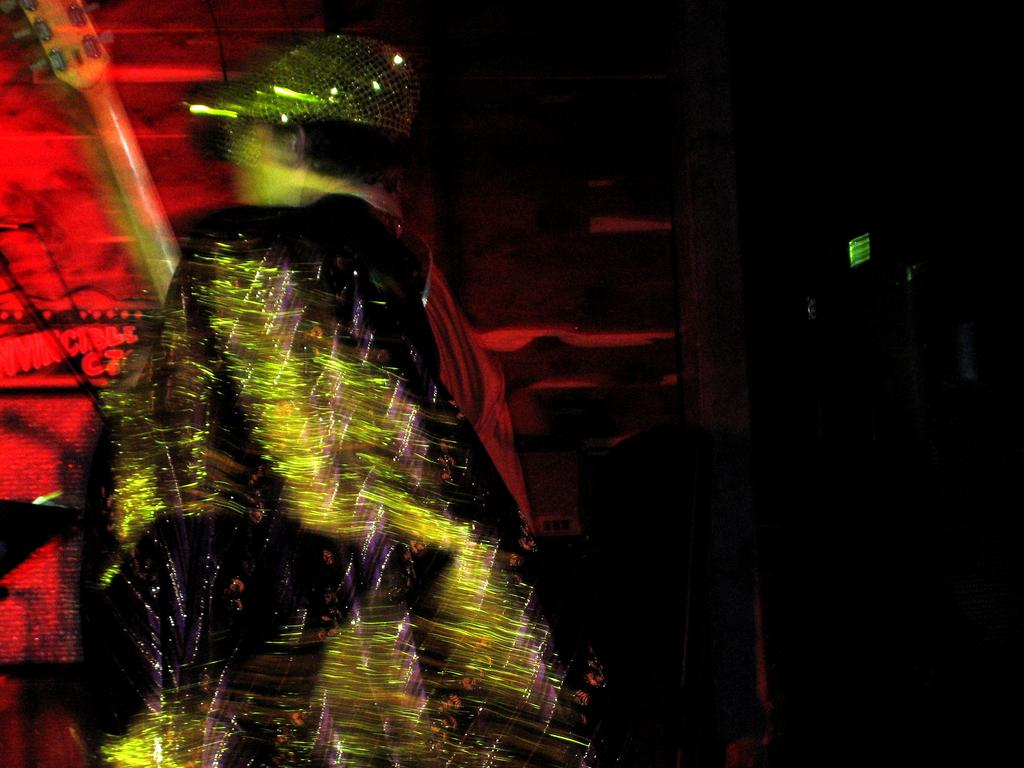What is the main subject of the image? There is a person in the image. What is the person holding in the image? The person is holding a guitar. What color light can be seen on the left side of the image? There is red light on the left side of the image. What type of haircut does the person have in the image? There is no information about the person's haircut in the image. What hobbies does the person have outside of playing the guitar? There is no information about the person's hobbies outside of playing the guitar in the image. 